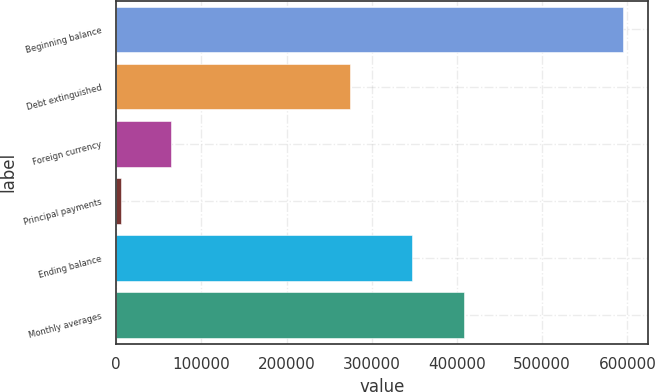<chart> <loc_0><loc_0><loc_500><loc_500><bar_chart><fcel>Beginning balance<fcel>Debt extinguished<fcel>Foreign currency<fcel>Principal payments<fcel>Ending balance<fcel>Monthly averages<nl><fcel>594199<fcel>274048<fcel>64696.6<fcel>5863<fcel>347474<fcel>408688<nl></chart> 